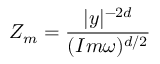<formula> <loc_0><loc_0><loc_500><loc_500>Z _ { m } = \frac { | y | ^ { - 2 d } } { ( I m \omega ) ^ { d / 2 } }</formula> 